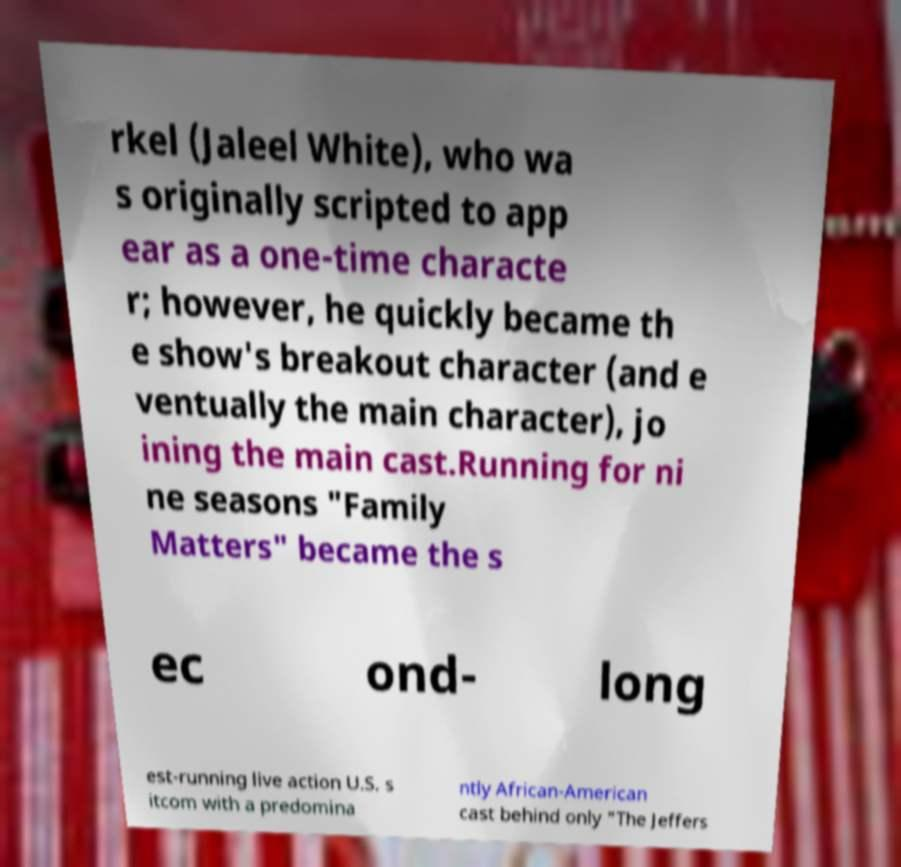Please read and relay the text visible in this image. What does it say? rkel (Jaleel White), who wa s originally scripted to app ear as a one-time characte r; however, he quickly became th e show's breakout character (and e ventually the main character), jo ining the main cast.Running for ni ne seasons "Family Matters" became the s ec ond- long est-running live action U.S. s itcom with a predomina ntly African-American cast behind only "The Jeffers 